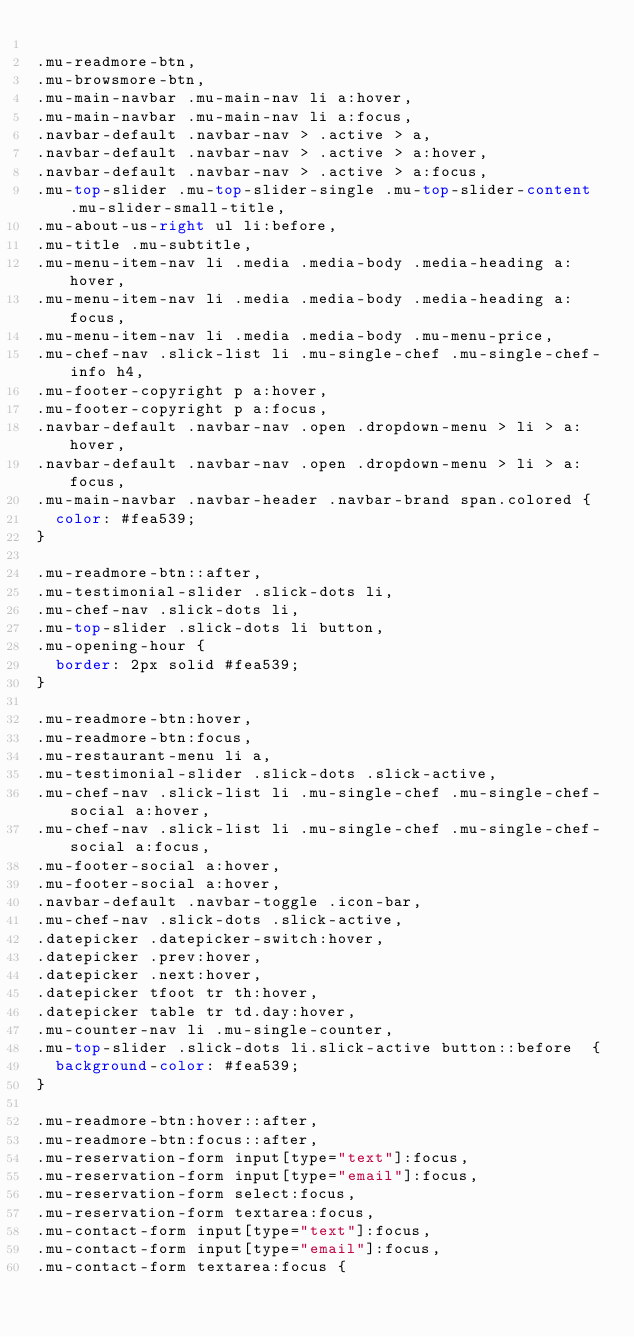<code> <loc_0><loc_0><loc_500><loc_500><_CSS_>
.mu-readmore-btn,
.mu-browsmore-btn,
.mu-main-navbar .mu-main-nav li a:hover, 
.mu-main-navbar .mu-main-nav li a:focus,
.navbar-default .navbar-nav > .active > a, 
.navbar-default .navbar-nav > .active > a:hover, 
.navbar-default .navbar-nav > .active > a:focus,
.mu-top-slider .mu-top-slider-single .mu-top-slider-content .mu-slider-small-title,
.mu-about-us-right ul li:before,
.mu-title .mu-subtitle,
.mu-menu-item-nav li .media .media-body .media-heading a:hover, 
.mu-menu-item-nav li .media .media-body .media-heading a:focus,
.mu-menu-item-nav li .media .media-body .mu-menu-price,
.mu-chef-nav .slick-list li .mu-single-chef .mu-single-chef-info h4,
.mu-footer-copyright p a:hover, 
.mu-footer-copyright p a:focus,
.navbar-default .navbar-nav .open .dropdown-menu > li > a:hover, 
.navbar-default .navbar-nav .open .dropdown-menu > li > a:focus,
.mu-main-navbar .navbar-header .navbar-brand span.colored {
  color: #fea539;
}

.mu-readmore-btn::after,
.mu-testimonial-slider .slick-dots li,
.mu-chef-nav .slick-dots li,
.mu-top-slider .slick-dots li button,
.mu-opening-hour {
  border: 2px solid #fea539;
}

.mu-readmore-btn:hover, 
.mu-readmore-btn:focus,
.mu-restaurant-menu li a,
.mu-testimonial-slider .slick-dots .slick-active,
.mu-chef-nav .slick-list li .mu-single-chef .mu-single-chef-social a:hover, 
.mu-chef-nav .slick-list li .mu-single-chef .mu-single-chef-social a:focus,
.mu-footer-social a:hover, 
.mu-footer-social a:hover,
.navbar-default .navbar-toggle .icon-bar,
.mu-chef-nav .slick-dots .slick-active,
.datepicker .datepicker-switch:hover, 
.datepicker .prev:hover, 
.datepicker .next:hover, 
.datepicker tfoot tr th:hover,
.datepicker table tr td.day:hover,
.mu-counter-nav li .mu-single-counter,
.mu-top-slider .slick-dots li.slick-active button::before  {
  background-color: #fea539;
}

.mu-readmore-btn:hover::after, 
.mu-readmore-btn:focus::after,
.mu-reservation-form input[type="text"]:focus,
.mu-reservation-form input[type="email"]:focus,
.mu-reservation-form select:focus,
.mu-reservation-form textarea:focus,
.mu-contact-form input[type="text"]:focus,
.mu-contact-form input[type="email"]:focus,
.mu-contact-form textarea:focus {</code> 